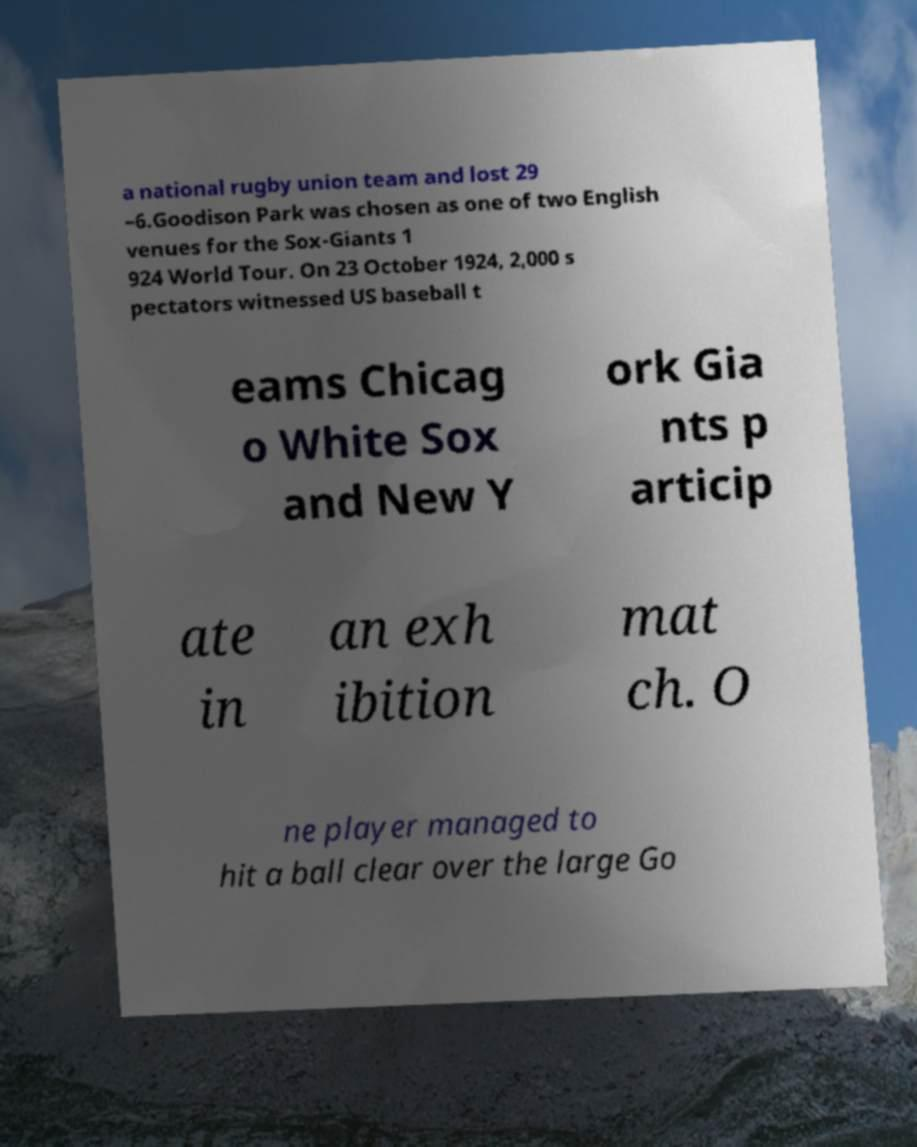Can you accurately transcribe the text from the provided image for me? a national rugby union team and lost 29 –6.Goodison Park was chosen as one of two English venues for the Sox-Giants 1 924 World Tour. On 23 October 1924, 2,000 s pectators witnessed US baseball t eams Chicag o White Sox and New Y ork Gia nts p articip ate in an exh ibition mat ch. O ne player managed to hit a ball clear over the large Go 